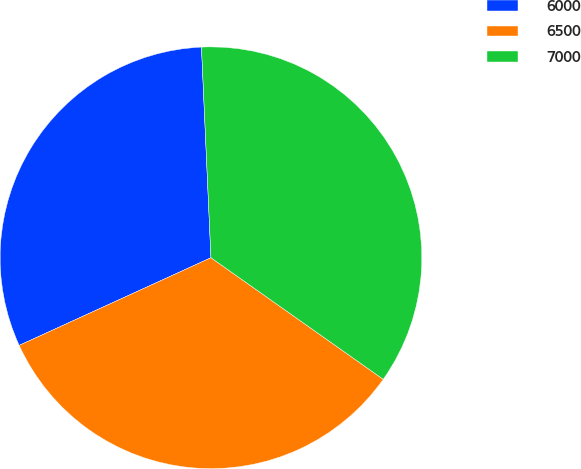<chart> <loc_0><loc_0><loc_500><loc_500><pie_chart><fcel>6000<fcel>6500<fcel>7000<nl><fcel>31.11%<fcel>33.4%<fcel>35.5%<nl></chart> 